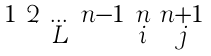<formula> <loc_0><loc_0><loc_500><loc_500>\begin{smallmatrix} 1 & 2 & \dots & n - 1 & n & n + 1 \\ & & L & & i & j \end{smallmatrix}</formula> 